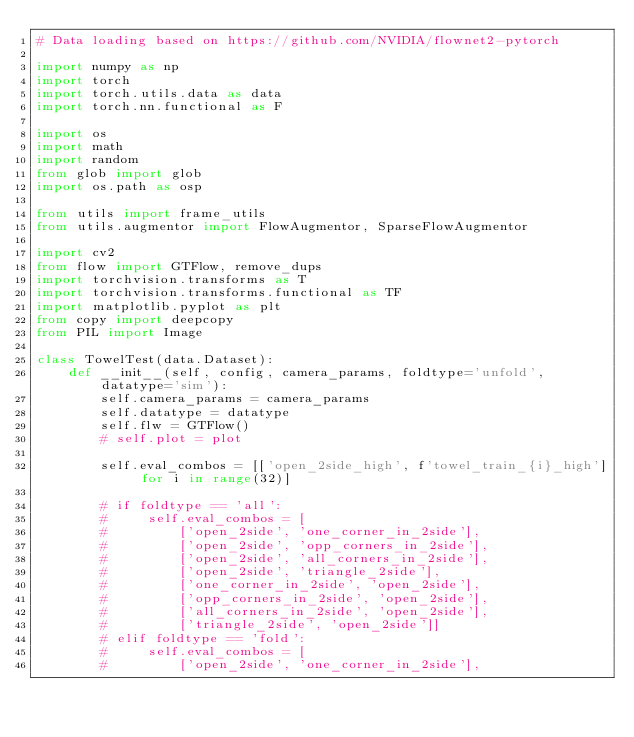Convert code to text. <code><loc_0><loc_0><loc_500><loc_500><_Python_># Data loading based on https://github.com/NVIDIA/flownet2-pytorch

import numpy as np
import torch
import torch.utils.data as data
import torch.nn.functional as F

import os
import math
import random
from glob import glob
import os.path as osp

from utils import frame_utils
from utils.augmentor import FlowAugmentor, SparseFlowAugmentor

import cv2
from flow import GTFlow, remove_dups
import torchvision.transforms as T
import torchvision.transforms.functional as TF
import matplotlib.pyplot as plt
from copy import deepcopy
from PIL import Image

class TowelTest(data.Dataset):
    def __init__(self, config, camera_params, foldtype='unfold', datatype='sim'):
        self.camera_params = camera_params
        self.datatype = datatype
        self.flw = GTFlow()
        # self.plot = plot

        self.eval_combos = [['open_2side_high', f'towel_train_{i}_high'] for i in range(32)]

        # if foldtype == 'all':
        #     self.eval_combos = [
        #         ['open_2side', 'one_corner_in_2side'],
        #         ['open_2side', 'opp_corners_in_2side'],
        #         ['open_2side', 'all_corners_in_2side'],
        #         ['open_2side', 'triangle_2side'],
        #         ['one_corner_in_2side', 'open_2side'],
        #         ['opp_corners_in_2side', 'open_2side'],
        #         ['all_corners_in_2side', 'open_2side'],
        #         ['triangle_2side', 'open_2side']]
        # elif foldtype == 'fold':
        #     self.eval_combos = [
        #         ['open_2side', 'one_corner_in_2side'],</code> 